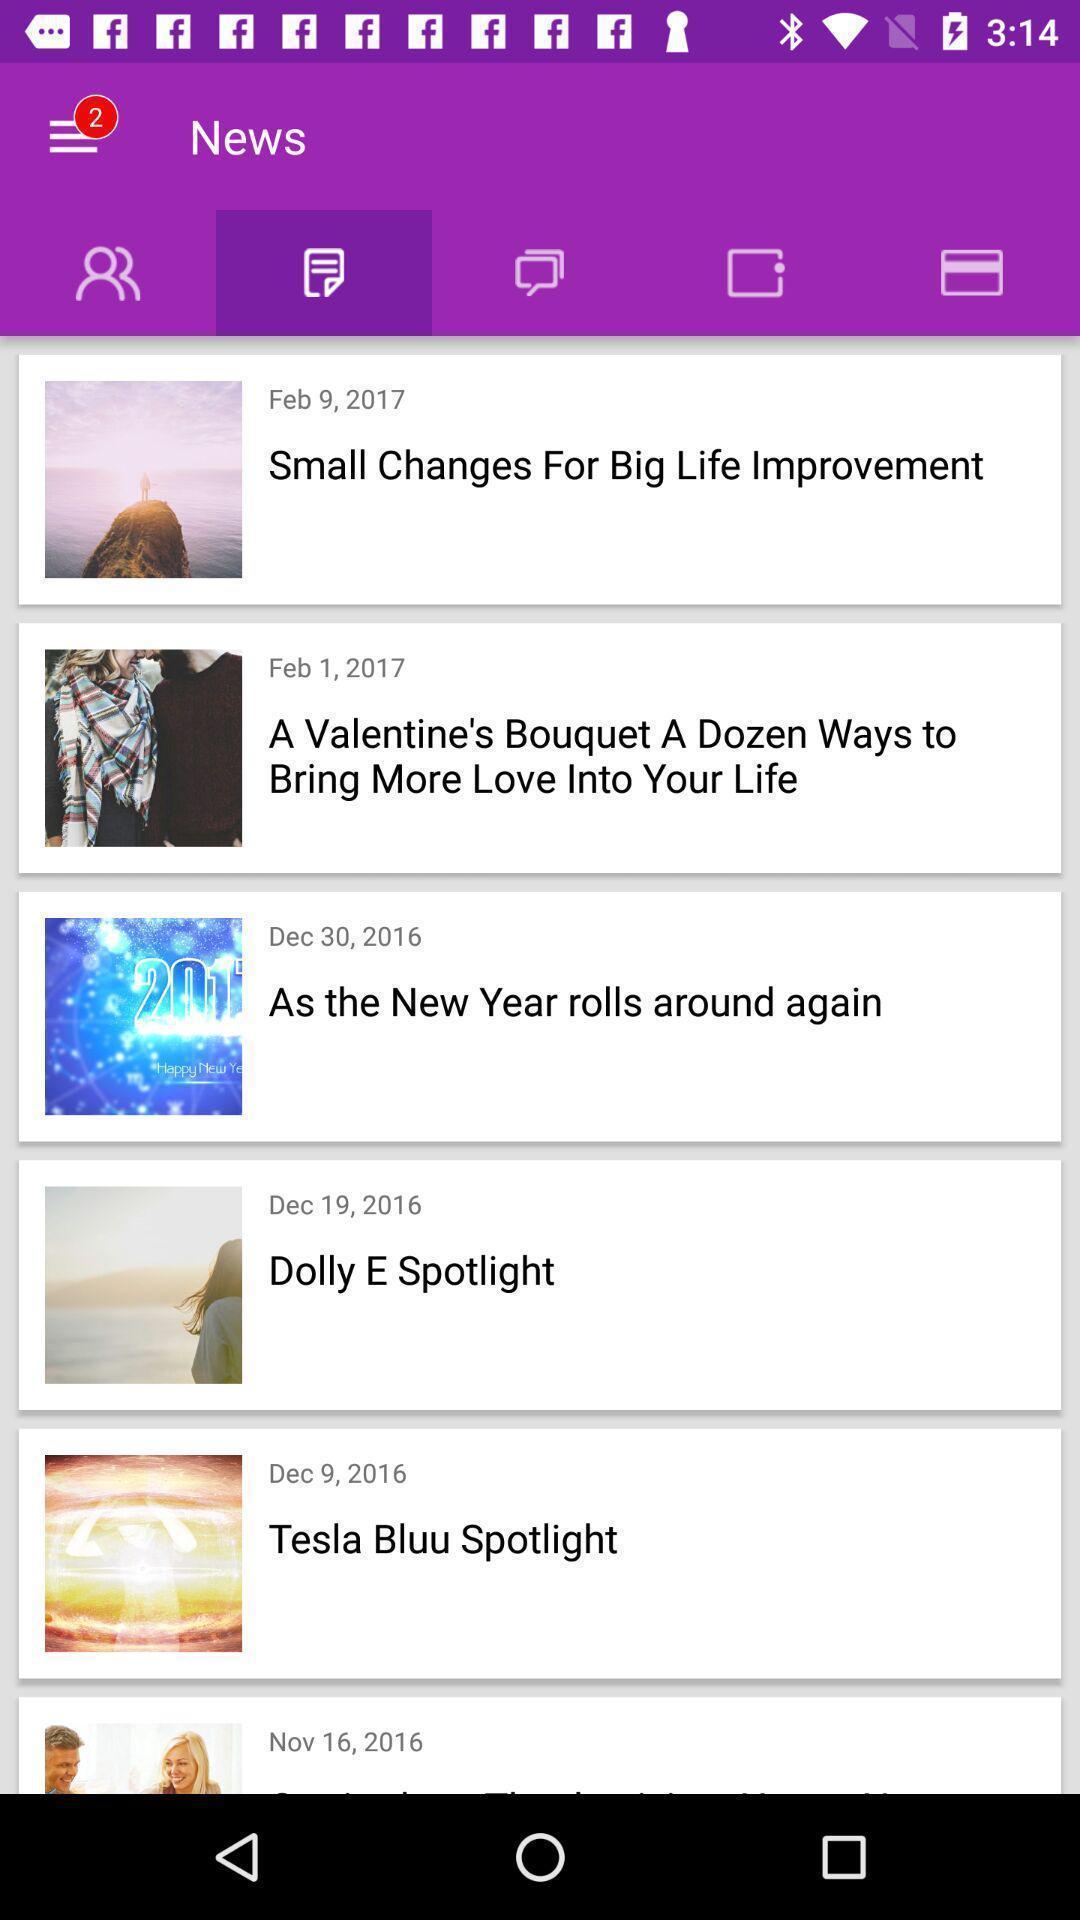Please provide a description for this image. Screen displaying news feed. 